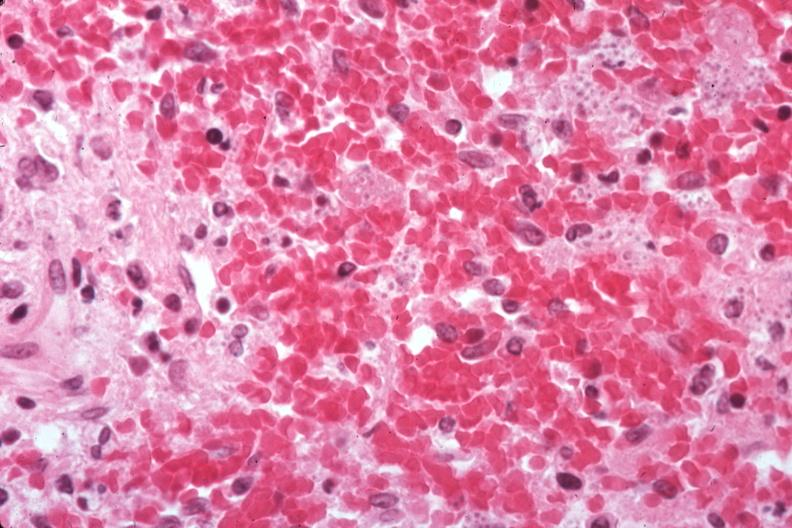s benign cystic teratoma present?
Answer the question using a single word or phrase. No 